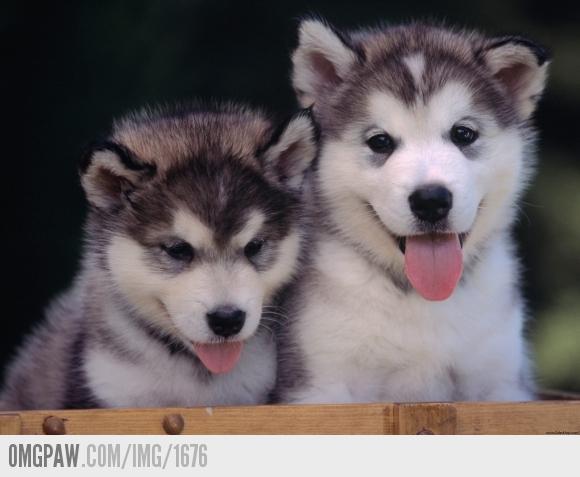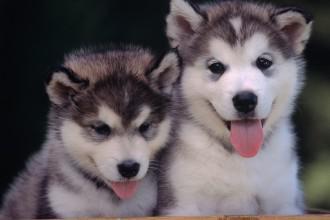The first image is the image on the left, the second image is the image on the right. Analyze the images presented: Is the assertion "Exactly two dogs have their tongues out." valid? Answer yes or no. No. 